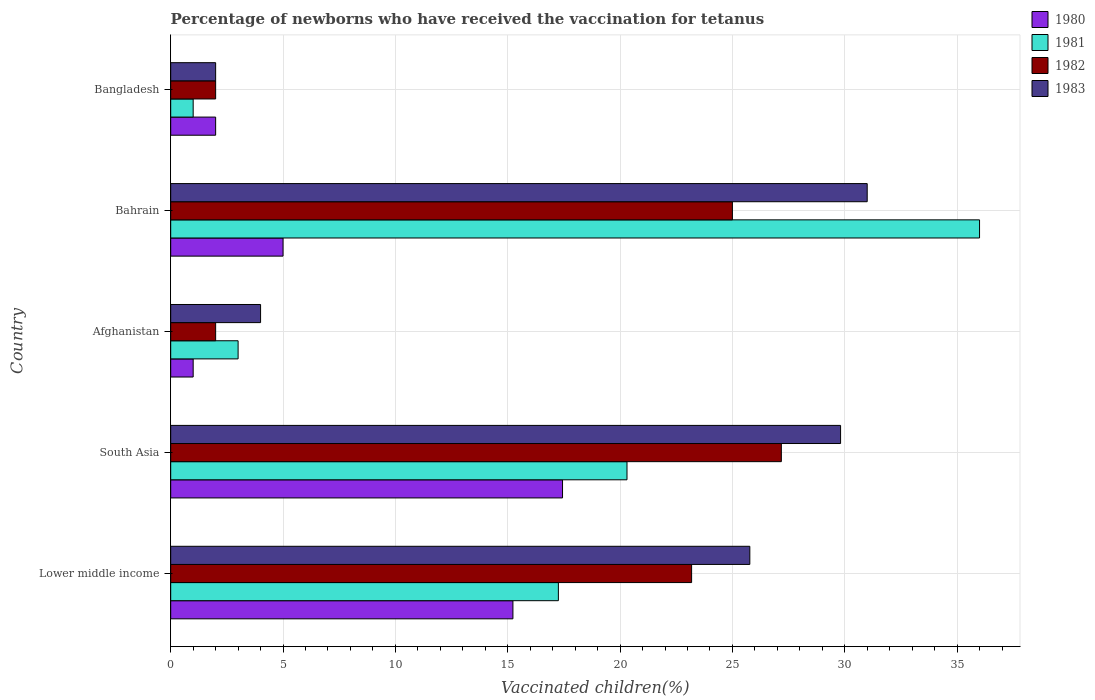How many different coloured bars are there?
Provide a succinct answer. 4. How many groups of bars are there?
Offer a very short reply. 5. What is the label of the 4th group of bars from the top?
Provide a succinct answer. South Asia. Across all countries, what is the minimum percentage of vaccinated children in 1980?
Provide a short and direct response. 1. In which country was the percentage of vaccinated children in 1983 maximum?
Offer a very short reply. Bahrain. What is the total percentage of vaccinated children in 1983 in the graph?
Ensure brevity in your answer.  92.59. What is the difference between the percentage of vaccinated children in 1981 in South Asia and the percentage of vaccinated children in 1982 in Afghanistan?
Your response must be concise. 18.31. What is the average percentage of vaccinated children in 1982 per country?
Make the answer very short. 15.87. What is the difference between the percentage of vaccinated children in 1981 and percentage of vaccinated children in 1980 in South Asia?
Provide a succinct answer. 2.87. What is the ratio of the percentage of vaccinated children in 1983 in Bahrain to that in Bangladesh?
Your answer should be compact. 15.5. Is the difference between the percentage of vaccinated children in 1981 in Bahrain and Bangladesh greater than the difference between the percentage of vaccinated children in 1980 in Bahrain and Bangladesh?
Provide a succinct answer. Yes. What is the difference between the highest and the second highest percentage of vaccinated children in 1982?
Offer a very short reply. 2.18. Is it the case that in every country, the sum of the percentage of vaccinated children in 1980 and percentage of vaccinated children in 1982 is greater than the sum of percentage of vaccinated children in 1981 and percentage of vaccinated children in 1983?
Provide a succinct answer. No. Are all the bars in the graph horizontal?
Provide a short and direct response. Yes. Does the graph contain any zero values?
Offer a terse response. No. Where does the legend appear in the graph?
Offer a terse response. Top right. How many legend labels are there?
Make the answer very short. 4. How are the legend labels stacked?
Your response must be concise. Vertical. What is the title of the graph?
Provide a short and direct response. Percentage of newborns who have received the vaccination for tetanus. Does "1976" appear as one of the legend labels in the graph?
Make the answer very short. No. What is the label or title of the X-axis?
Offer a terse response. Vaccinated children(%). What is the label or title of the Y-axis?
Your response must be concise. Country. What is the Vaccinated children(%) in 1980 in Lower middle income?
Give a very brief answer. 15.23. What is the Vaccinated children(%) of 1981 in Lower middle income?
Offer a terse response. 17.25. What is the Vaccinated children(%) in 1982 in Lower middle income?
Provide a succinct answer. 23.18. What is the Vaccinated children(%) in 1983 in Lower middle income?
Your response must be concise. 25.78. What is the Vaccinated children(%) of 1980 in South Asia?
Offer a very short reply. 17.44. What is the Vaccinated children(%) of 1981 in South Asia?
Provide a short and direct response. 20.31. What is the Vaccinated children(%) in 1982 in South Asia?
Provide a succinct answer. 27.18. What is the Vaccinated children(%) in 1983 in South Asia?
Provide a short and direct response. 29.81. What is the Vaccinated children(%) of 1982 in Afghanistan?
Provide a short and direct response. 2. What is the Vaccinated children(%) of 1983 in Afghanistan?
Provide a succinct answer. 4. What is the Vaccinated children(%) in 1980 in Bahrain?
Your answer should be very brief. 5. What is the Vaccinated children(%) in 1981 in Bahrain?
Your response must be concise. 36. What is the Vaccinated children(%) of 1982 in Bangladesh?
Your answer should be compact. 2. Across all countries, what is the maximum Vaccinated children(%) of 1980?
Offer a terse response. 17.44. Across all countries, what is the maximum Vaccinated children(%) in 1982?
Make the answer very short. 27.18. Across all countries, what is the minimum Vaccinated children(%) of 1980?
Your answer should be very brief. 1. Across all countries, what is the minimum Vaccinated children(%) in 1981?
Provide a succinct answer. 1. Across all countries, what is the minimum Vaccinated children(%) in 1983?
Give a very brief answer. 2. What is the total Vaccinated children(%) in 1980 in the graph?
Ensure brevity in your answer.  40.67. What is the total Vaccinated children(%) in 1981 in the graph?
Make the answer very short. 77.56. What is the total Vaccinated children(%) in 1982 in the graph?
Make the answer very short. 79.36. What is the total Vaccinated children(%) of 1983 in the graph?
Your answer should be compact. 92.59. What is the difference between the Vaccinated children(%) of 1980 in Lower middle income and that in South Asia?
Offer a terse response. -2.21. What is the difference between the Vaccinated children(%) of 1981 in Lower middle income and that in South Asia?
Give a very brief answer. -3.05. What is the difference between the Vaccinated children(%) in 1982 in Lower middle income and that in South Asia?
Offer a very short reply. -3.99. What is the difference between the Vaccinated children(%) in 1983 in Lower middle income and that in South Asia?
Your answer should be very brief. -4.04. What is the difference between the Vaccinated children(%) of 1980 in Lower middle income and that in Afghanistan?
Provide a short and direct response. 14.23. What is the difference between the Vaccinated children(%) in 1981 in Lower middle income and that in Afghanistan?
Provide a short and direct response. 14.25. What is the difference between the Vaccinated children(%) in 1982 in Lower middle income and that in Afghanistan?
Your response must be concise. 21.18. What is the difference between the Vaccinated children(%) in 1983 in Lower middle income and that in Afghanistan?
Make the answer very short. 21.78. What is the difference between the Vaccinated children(%) in 1980 in Lower middle income and that in Bahrain?
Ensure brevity in your answer.  10.23. What is the difference between the Vaccinated children(%) of 1981 in Lower middle income and that in Bahrain?
Ensure brevity in your answer.  -18.75. What is the difference between the Vaccinated children(%) in 1982 in Lower middle income and that in Bahrain?
Offer a terse response. -1.82. What is the difference between the Vaccinated children(%) in 1983 in Lower middle income and that in Bahrain?
Offer a terse response. -5.22. What is the difference between the Vaccinated children(%) of 1980 in Lower middle income and that in Bangladesh?
Your answer should be very brief. 13.23. What is the difference between the Vaccinated children(%) in 1981 in Lower middle income and that in Bangladesh?
Ensure brevity in your answer.  16.25. What is the difference between the Vaccinated children(%) in 1982 in Lower middle income and that in Bangladesh?
Your answer should be compact. 21.18. What is the difference between the Vaccinated children(%) of 1983 in Lower middle income and that in Bangladesh?
Make the answer very short. 23.78. What is the difference between the Vaccinated children(%) of 1980 in South Asia and that in Afghanistan?
Your response must be concise. 16.44. What is the difference between the Vaccinated children(%) in 1981 in South Asia and that in Afghanistan?
Offer a very short reply. 17.31. What is the difference between the Vaccinated children(%) in 1982 in South Asia and that in Afghanistan?
Your answer should be compact. 25.18. What is the difference between the Vaccinated children(%) of 1983 in South Asia and that in Afghanistan?
Offer a very short reply. 25.81. What is the difference between the Vaccinated children(%) in 1980 in South Asia and that in Bahrain?
Offer a very short reply. 12.44. What is the difference between the Vaccinated children(%) in 1981 in South Asia and that in Bahrain?
Offer a very short reply. -15.69. What is the difference between the Vaccinated children(%) in 1982 in South Asia and that in Bahrain?
Offer a very short reply. 2.18. What is the difference between the Vaccinated children(%) in 1983 in South Asia and that in Bahrain?
Make the answer very short. -1.19. What is the difference between the Vaccinated children(%) in 1980 in South Asia and that in Bangladesh?
Your answer should be very brief. 15.44. What is the difference between the Vaccinated children(%) in 1981 in South Asia and that in Bangladesh?
Keep it short and to the point. 19.31. What is the difference between the Vaccinated children(%) in 1982 in South Asia and that in Bangladesh?
Offer a very short reply. 25.18. What is the difference between the Vaccinated children(%) in 1983 in South Asia and that in Bangladesh?
Keep it short and to the point. 27.81. What is the difference between the Vaccinated children(%) of 1981 in Afghanistan and that in Bahrain?
Offer a very short reply. -33. What is the difference between the Vaccinated children(%) of 1982 in Afghanistan and that in Bahrain?
Make the answer very short. -23. What is the difference between the Vaccinated children(%) of 1983 in Afghanistan and that in Bahrain?
Your response must be concise. -27. What is the difference between the Vaccinated children(%) in 1981 in Afghanistan and that in Bangladesh?
Your answer should be very brief. 2. What is the difference between the Vaccinated children(%) of 1983 in Bahrain and that in Bangladesh?
Your answer should be compact. 29. What is the difference between the Vaccinated children(%) of 1980 in Lower middle income and the Vaccinated children(%) of 1981 in South Asia?
Provide a succinct answer. -5.08. What is the difference between the Vaccinated children(%) of 1980 in Lower middle income and the Vaccinated children(%) of 1982 in South Asia?
Provide a short and direct response. -11.95. What is the difference between the Vaccinated children(%) of 1980 in Lower middle income and the Vaccinated children(%) of 1983 in South Asia?
Your response must be concise. -14.58. What is the difference between the Vaccinated children(%) of 1981 in Lower middle income and the Vaccinated children(%) of 1982 in South Asia?
Make the answer very short. -9.92. What is the difference between the Vaccinated children(%) of 1981 in Lower middle income and the Vaccinated children(%) of 1983 in South Asia?
Your answer should be very brief. -12.56. What is the difference between the Vaccinated children(%) in 1982 in Lower middle income and the Vaccinated children(%) in 1983 in South Asia?
Your answer should be compact. -6.63. What is the difference between the Vaccinated children(%) of 1980 in Lower middle income and the Vaccinated children(%) of 1981 in Afghanistan?
Offer a very short reply. 12.23. What is the difference between the Vaccinated children(%) in 1980 in Lower middle income and the Vaccinated children(%) in 1982 in Afghanistan?
Provide a short and direct response. 13.23. What is the difference between the Vaccinated children(%) in 1980 in Lower middle income and the Vaccinated children(%) in 1983 in Afghanistan?
Give a very brief answer. 11.23. What is the difference between the Vaccinated children(%) in 1981 in Lower middle income and the Vaccinated children(%) in 1982 in Afghanistan?
Provide a short and direct response. 15.25. What is the difference between the Vaccinated children(%) of 1981 in Lower middle income and the Vaccinated children(%) of 1983 in Afghanistan?
Keep it short and to the point. 13.25. What is the difference between the Vaccinated children(%) of 1982 in Lower middle income and the Vaccinated children(%) of 1983 in Afghanistan?
Provide a succinct answer. 19.18. What is the difference between the Vaccinated children(%) in 1980 in Lower middle income and the Vaccinated children(%) in 1981 in Bahrain?
Keep it short and to the point. -20.77. What is the difference between the Vaccinated children(%) of 1980 in Lower middle income and the Vaccinated children(%) of 1982 in Bahrain?
Your answer should be compact. -9.77. What is the difference between the Vaccinated children(%) of 1980 in Lower middle income and the Vaccinated children(%) of 1983 in Bahrain?
Your answer should be compact. -15.77. What is the difference between the Vaccinated children(%) of 1981 in Lower middle income and the Vaccinated children(%) of 1982 in Bahrain?
Ensure brevity in your answer.  -7.75. What is the difference between the Vaccinated children(%) of 1981 in Lower middle income and the Vaccinated children(%) of 1983 in Bahrain?
Keep it short and to the point. -13.75. What is the difference between the Vaccinated children(%) in 1982 in Lower middle income and the Vaccinated children(%) in 1983 in Bahrain?
Your answer should be compact. -7.82. What is the difference between the Vaccinated children(%) in 1980 in Lower middle income and the Vaccinated children(%) in 1981 in Bangladesh?
Ensure brevity in your answer.  14.23. What is the difference between the Vaccinated children(%) of 1980 in Lower middle income and the Vaccinated children(%) of 1982 in Bangladesh?
Keep it short and to the point. 13.23. What is the difference between the Vaccinated children(%) in 1980 in Lower middle income and the Vaccinated children(%) in 1983 in Bangladesh?
Make the answer very short. 13.23. What is the difference between the Vaccinated children(%) in 1981 in Lower middle income and the Vaccinated children(%) in 1982 in Bangladesh?
Keep it short and to the point. 15.25. What is the difference between the Vaccinated children(%) in 1981 in Lower middle income and the Vaccinated children(%) in 1983 in Bangladesh?
Make the answer very short. 15.25. What is the difference between the Vaccinated children(%) of 1982 in Lower middle income and the Vaccinated children(%) of 1983 in Bangladesh?
Make the answer very short. 21.18. What is the difference between the Vaccinated children(%) in 1980 in South Asia and the Vaccinated children(%) in 1981 in Afghanistan?
Make the answer very short. 14.44. What is the difference between the Vaccinated children(%) in 1980 in South Asia and the Vaccinated children(%) in 1982 in Afghanistan?
Provide a succinct answer. 15.44. What is the difference between the Vaccinated children(%) in 1980 in South Asia and the Vaccinated children(%) in 1983 in Afghanistan?
Keep it short and to the point. 13.44. What is the difference between the Vaccinated children(%) in 1981 in South Asia and the Vaccinated children(%) in 1982 in Afghanistan?
Make the answer very short. 18.31. What is the difference between the Vaccinated children(%) of 1981 in South Asia and the Vaccinated children(%) of 1983 in Afghanistan?
Ensure brevity in your answer.  16.31. What is the difference between the Vaccinated children(%) of 1982 in South Asia and the Vaccinated children(%) of 1983 in Afghanistan?
Your answer should be very brief. 23.18. What is the difference between the Vaccinated children(%) in 1980 in South Asia and the Vaccinated children(%) in 1981 in Bahrain?
Your answer should be compact. -18.56. What is the difference between the Vaccinated children(%) of 1980 in South Asia and the Vaccinated children(%) of 1982 in Bahrain?
Offer a terse response. -7.56. What is the difference between the Vaccinated children(%) of 1980 in South Asia and the Vaccinated children(%) of 1983 in Bahrain?
Ensure brevity in your answer.  -13.56. What is the difference between the Vaccinated children(%) of 1981 in South Asia and the Vaccinated children(%) of 1982 in Bahrain?
Offer a very short reply. -4.69. What is the difference between the Vaccinated children(%) in 1981 in South Asia and the Vaccinated children(%) in 1983 in Bahrain?
Your answer should be compact. -10.69. What is the difference between the Vaccinated children(%) of 1982 in South Asia and the Vaccinated children(%) of 1983 in Bahrain?
Make the answer very short. -3.82. What is the difference between the Vaccinated children(%) in 1980 in South Asia and the Vaccinated children(%) in 1981 in Bangladesh?
Provide a succinct answer. 16.44. What is the difference between the Vaccinated children(%) of 1980 in South Asia and the Vaccinated children(%) of 1982 in Bangladesh?
Offer a terse response. 15.44. What is the difference between the Vaccinated children(%) in 1980 in South Asia and the Vaccinated children(%) in 1983 in Bangladesh?
Your response must be concise. 15.44. What is the difference between the Vaccinated children(%) of 1981 in South Asia and the Vaccinated children(%) of 1982 in Bangladesh?
Make the answer very short. 18.31. What is the difference between the Vaccinated children(%) in 1981 in South Asia and the Vaccinated children(%) in 1983 in Bangladesh?
Provide a short and direct response. 18.31. What is the difference between the Vaccinated children(%) of 1982 in South Asia and the Vaccinated children(%) of 1983 in Bangladesh?
Provide a short and direct response. 25.18. What is the difference between the Vaccinated children(%) in 1980 in Afghanistan and the Vaccinated children(%) in 1981 in Bahrain?
Your answer should be very brief. -35. What is the difference between the Vaccinated children(%) in 1980 in Afghanistan and the Vaccinated children(%) in 1982 in Bahrain?
Offer a very short reply. -24. What is the difference between the Vaccinated children(%) in 1981 in Afghanistan and the Vaccinated children(%) in 1983 in Bahrain?
Give a very brief answer. -28. What is the difference between the Vaccinated children(%) in 1980 in Afghanistan and the Vaccinated children(%) in 1981 in Bangladesh?
Offer a very short reply. 0. What is the difference between the Vaccinated children(%) in 1980 in Afghanistan and the Vaccinated children(%) in 1982 in Bangladesh?
Your answer should be very brief. -1. What is the difference between the Vaccinated children(%) of 1980 in Afghanistan and the Vaccinated children(%) of 1983 in Bangladesh?
Ensure brevity in your answer.  -1. What is the difference between the Vaccinated children(%) in 1981 in Afghanistan and the Vaccinated children(%) in 1982 in Bangladesh?
Offer a very short reply. 1. What is the difference between the Vaccinated children(%) of 1981 in Afghanistan and the Vaccinated children(%) of 1983 in Bangladesh?
Keep it short and to the point. 1. What is the difference between the Vaccinated children(%) in 1982 in Afghanistan and the Vaccinated children(%) in 1983 in Bangladesh?
Offer a terse response. 0. What is the difference between the Vaccinated children(%) of 1980 in Bahrain and the Vaccinated children(%) of 1981 in Bangladesh?
Your answer should be very brief. 4. What is the difference between the Vaccinated children(%) in 1980 in Bahrain and the Vaccinated children(%) in 1982 in Bangladesh?
Offer a terse response. 3. What is the difference between the Vaccinated children(%) of 1981 in Bahrain and the Vaccinated children(%) of 1982 in Bangladesh?
Give a very brief answer. 34. What is the difference between the Vaccinated children(%) of 1981 in Bahrain and the Vaccinated children(%) of 1983 in Bangladesh?
Your answer should be very brief. 34. What is the average Vaccinated children(%) of 1980 per country?
Offer a very short reply. 8.13. What is the average Vaccinated children(%) of 1981 per country?
Offer a terse response. 15.51. What is the average Vaccinated children(%) in 1982 per country?
Offer a very short reply. 15.87. What is the average Vaccinated children(%) of 1983 per country?
Make the answer very short. 18.52. What is the difference between the Vaccinated children(%) of 1980 and Vaccinated children(%) of 1981 in Lower middle income?
Your answer should be compact. -2.02. What is the difference between the Vaccinated children(%) of 1980 and Vaccinated children(%) of 1982 in Lower middle income?
Offer a very short reply. -7.95. What is the difference between the Vaccinated children(%) of 1980 and Vaccinated children(%) of 1983 in Lower middle income?
Offer a very short reply. -10.54. What is the difference between the Vaccinated children(%) of 1981 and Vaccinated children(%) of 1982 in Lower middle income?
Your answer should be very brief. -5.93. What is the difference between the Vaccinated children(%) in 1981 and Vaccinated children(%) in 1983 in Lower middle income?
Give a very brief answer. -8.52. What is the difference between the Vaccinated children(%) in 1982 and Vaccinated children(%) in 1983 in Lower middle income?
Ensure brevity in your answer.  -2.59. What is the difference between the Vaccinated children(%) in 1980 and Vaccinated children(%) in 1981 in South Asia?
Offer a terse response. -2.87. What is the difference between the Vaccinated children(%) of 1980 and Vaccinated children(%) of 1982 in South Asia?
Your answer should be very brief. -9.74. What is the difference between the Vaccinated children(%) in 1980 and Vaccinated children(%) in 1983 in South Asia?
Offer a terse response. -12.37. What is the difference between the Vaccinated children(%) of 1981 and Vaccinated children(%) of 1982 in South Asia?
Provide a succinct answer. -6.87. What is the difference between the Vaccinated children(%) in 1981 and Vaccinated children(%) in 1983 in South Asia?
Make the answer very short. -9.51. What is the difference between the Vaccinated children(%) of 1982 and Vaccinated children(%) of 1983 in South Asia?
Provide a succinct answer. -2.64. What is the difference between the Vaccinated children(%) in 1980 and Vaccinated children(%) in 1981 in Afghanistan?
Offer a very short reply. -2. What is the difference between the Vaccinated children(%) of 1980 and Vaccinated children(%) of 1981 in Bahrain?
Your response must be concise. -31. What is the difference between the Vaccinated children(%) of 1980 and Vaccinated children(%) of 1982 in Bahrain?
Ensure brevity in your answer.  -20. What is the difference between the Vaccinated children(%) of 1980 and Vaccinated children(%) of 1983 in Bahrain?
Provide a short and direct response. -26. What is the difference between the Vaccinated children(%) in 1981 and Vaccinated children(%) in 1982 in Bahrain?
Offer a terse response. 11. What is the difference between the Vaccinated children(%) in 1981 and Vaccinated children(%) in 1983 in Bahrain?
Provide a short and direct response. 5. What is the difference between the Vaccinated children(%) in 1982 and Vaccinated children(%) in 1983 in Bahrain?
Provide a short and direct response. -6. What is the difference between the Vaccinated children(%) of 1981 and Vaccinated children(%) of 1982 in Bangladesh?
Your response must be concise. -1. What is the difference between the Vaccinated children(%) of 1981 and Vaccinated children(%) of 1983 in Bangladesh?
Your answer should be compact. -1. What is the ratio of the Vaccinated children(%) of 1980 in Lower middle income to that in South Asia?
Offer a terse response. 0.87. What is the ratio of the Vaccinated children(%) in 1981 in Lower middle income to that in South Asia?
Your answer should be very brief. 0.85. What is the ratio of the Vaccinated children(%) of 1982 in Lower middle income to that in South Asia?
Your response must be concise. 0.85. What is the ratio of the Vaccinated children(%) in 1983 in Lower middle income to that in South Asia?
Provide a succinct answer. 0.86. What is the ratio of the Vaccinated children(%) of 1980 in Lower middle income to that in Afghanistan?
Offer a terse response. 15.23. What is the ratio of the Vaccinated children(%) in 1981 in Lower middle income to that in Afghanistan?
Offer a terse response. 5.75. What is the ratio of the Vaccinated children(%) of 1982 in Lower middle income to that in Afghanistan?
Ensure brevity in your answer.  11.59. What is the ratio of the Vaccinated children(%) of 1983 in Lower middle income to that in Afghanistan?
Offer a very short reply. 6.44. What is the ratio of the Vaccinated children(%) in 1980 in Lower middle income to that in Bahrain?
Provide a succinct answer. 3.05. What is the ratio of the Vaccinated children(%) in 1981 in Lower middle income to that in Bahrain?
Offer a terse response. 0.48. What is the ratio of the Vaccinated children(%) in 1982 in Lower middle income to that in Bahrain?
Give a very brief answer. 0.93. What is the ratio of the Vaccinated children(%) in 1983 in Lower middle income to that in Bahrain?
Offer a terse response. 0.83. What is the ratio of the Vaccinated children(%) of 1980 in Lower middle income to that in Bangladesh?
Your answer should be compact. 7.62. What is the ratio of the Vaccinated children(%) in 1981 in Lower middle income to that in Bangladesh?
Make the answer very short. 17.25. What is the ratio of the Vaccinated children(%) of 1982 in Lower middle income to that in Bangladesh?
Provide a succinct answer. 11.59. What is the ratio of the Vaccinated children(%) of 1983 in Lower middle income to that in Bangladesh?
Offer a terse response. 12.89. What is the ratio of the Vaccinated children(%) in 1980 in South Asia to that in Afghanistan?
Offer a terse response. 17.44. What is the ratio of the Vaccinated children(%) in 1981 in South Asia to that in Afghanistan?
Give a very brief answer. 6.77. What is the ratio of the Vaccinated children(%) in 1982 in South Asia to that in Afghanistan?
Make the answer very short. 13.59. What is the ratio of the Vaccinated children(%) of 1983 in South Asia to that in Afghanistan?
Your answer should be compact. 7.45. What is the ratio of the Vaccinated children(%) in 1980 in South Asia to that in Bahrain?
Provide a succinct answer. 3.49. What is the ratio of the Vaccinated children(%) in 1981 in South Asia to that in Bahrain?
Give a very brief answer. 0.56. What is the ratio of the Vaccinated children(%) of 1982 in South Asia to that in Bahrain?
Make the answer very short. 1.09. What is the ratio of the Vaccinated children(%) in 1983 in South Asia to that in Bahrain?
Your response must be concise. 0.96. What is the ratio of the Vaccinated children(%) in 1980 in South Asia to that in Bangladesh?
Your answer should be very brief. 8.72. What is the ratio of the Vaccinated children(%) in 1981 in South Asia to that in Bangladesh?
Offer a very short reply. 20.31. What is the ratio of the Vaccinated children(%) in 1982 in South Asia to that in Bangladesh?
Your response must be concise. 13.59. What is the ratio of the Vaccinated children(%) of 1983 in South Asia to that in Bangladesh?
Your response must be concise. 14.91. What is the ratio of the Vaccinated children(%) of 1981 in Afghanistan to that in Bahrain?
Make the answer very short. 0.08. What is the ratio of the Vaccinated children(%) in 1983 in Afghanistan to that in Bahrain?
Make the answer very short. 0.13. What is the ratio of the Vaccinated children(%) of 1980 in Afghanistan to that in Bangladesh?
Ensure brevity in your answer.  0.5. What is the ratio of the Vaccinated children(%) of 1983 in Afghanistan to that in Bangladesh?
Provide a succinct answer. 2. What is the ratio of the Vaccinated children(%) of 1980 in Bahrain to that in Bangladesh?
Give a very brief answer. 2.5. What is the ratio of the Vaccinated children(%) of 1981 in Bahrain to that in Bangladesh?
Offer a very short reply. 36. What is the ratio of the Vaccinated children(%) of 1982 in Bahrain to that in Bangladesh?
Keep it short and to the point. 12.5. What is the difference between the highest and the second highest Vaccinated children(%) in 1980?
Provide a short and direct response. 2.21. What is the difference between the highest and the second highest Vaccinated children(%) in 1981?
Give a very brief answer. 15.69. What is the difference between the highest and the second highest Vaccinated children(%) of 1982?
Provide a short and direct response. 2.18. What is the difference between the highest and the second highest Vaccinated children(%) of 1983?
Provide a succinct answer. 1.19. What is the difference between the highest and the lowest Vaccinated children(%) of 1980?
Provide a succinct answer. 16.44. What is the difference between the highest and the lowest Vaccinated children(%) of 1981?
Your response must be concise. 35. What is the difference between the highest and the lowest Vaccinated children(%) in 1982?
Your response must be concise. 25.18. 